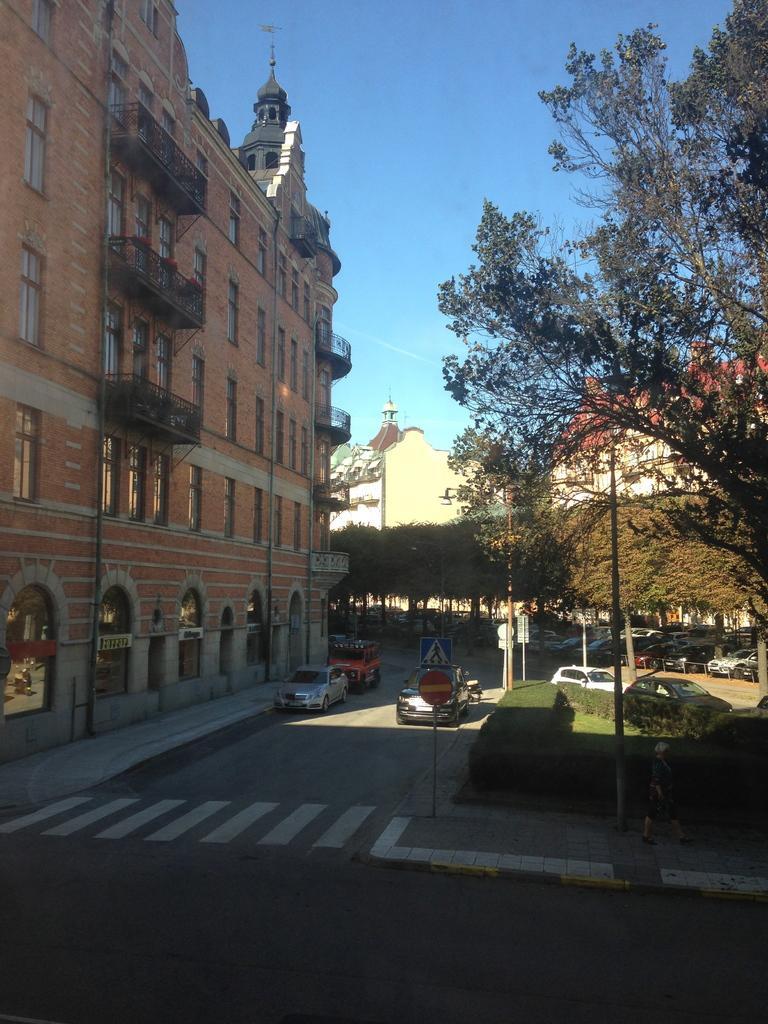Please provide a concise description of this image. In this image there is a road. There are cars. There are buildings. There are trees and grass. There is a sky. 